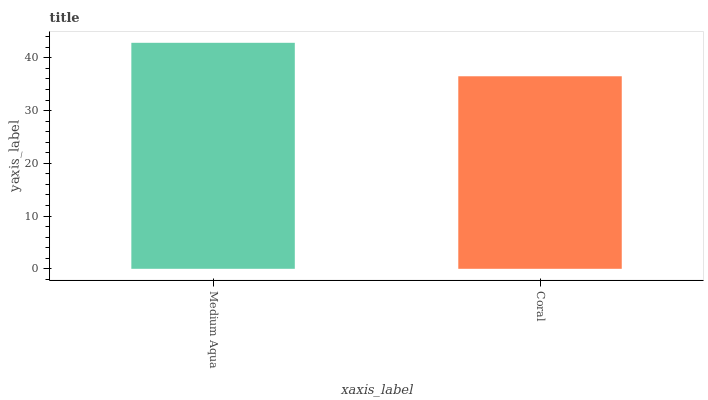Is Coral the maximum?
Answer yes or no. No. Is Medium Aqua greater than Coral?
Answer yes or no. Yes. Is Coral less than Medium Aqua?
Answer yes or no. Yes. Is Coral greater than Medium Aqua?
Answer yes or no. No. Is Medium Aqua less than Coral?
Answer yes or no. No. Is Medium Aqua the high median?
Answer yes or no. Yes. Is Coral the low median?
Answer yes or no. Yes. Is Coral the high median?
Answer yes or no. No. Is Medium Aqua the low median?
Answer yes or no. No. 